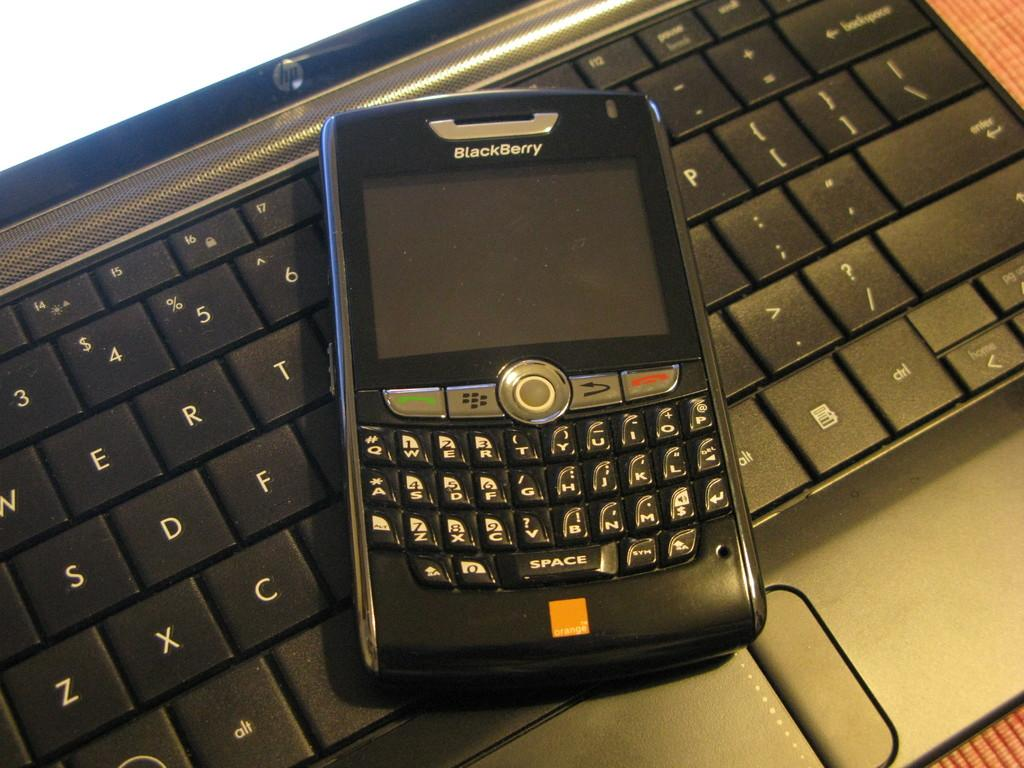<image>
Relay a brief, clear account of the picture shown. An old style Blackberry phone on a keyboard 